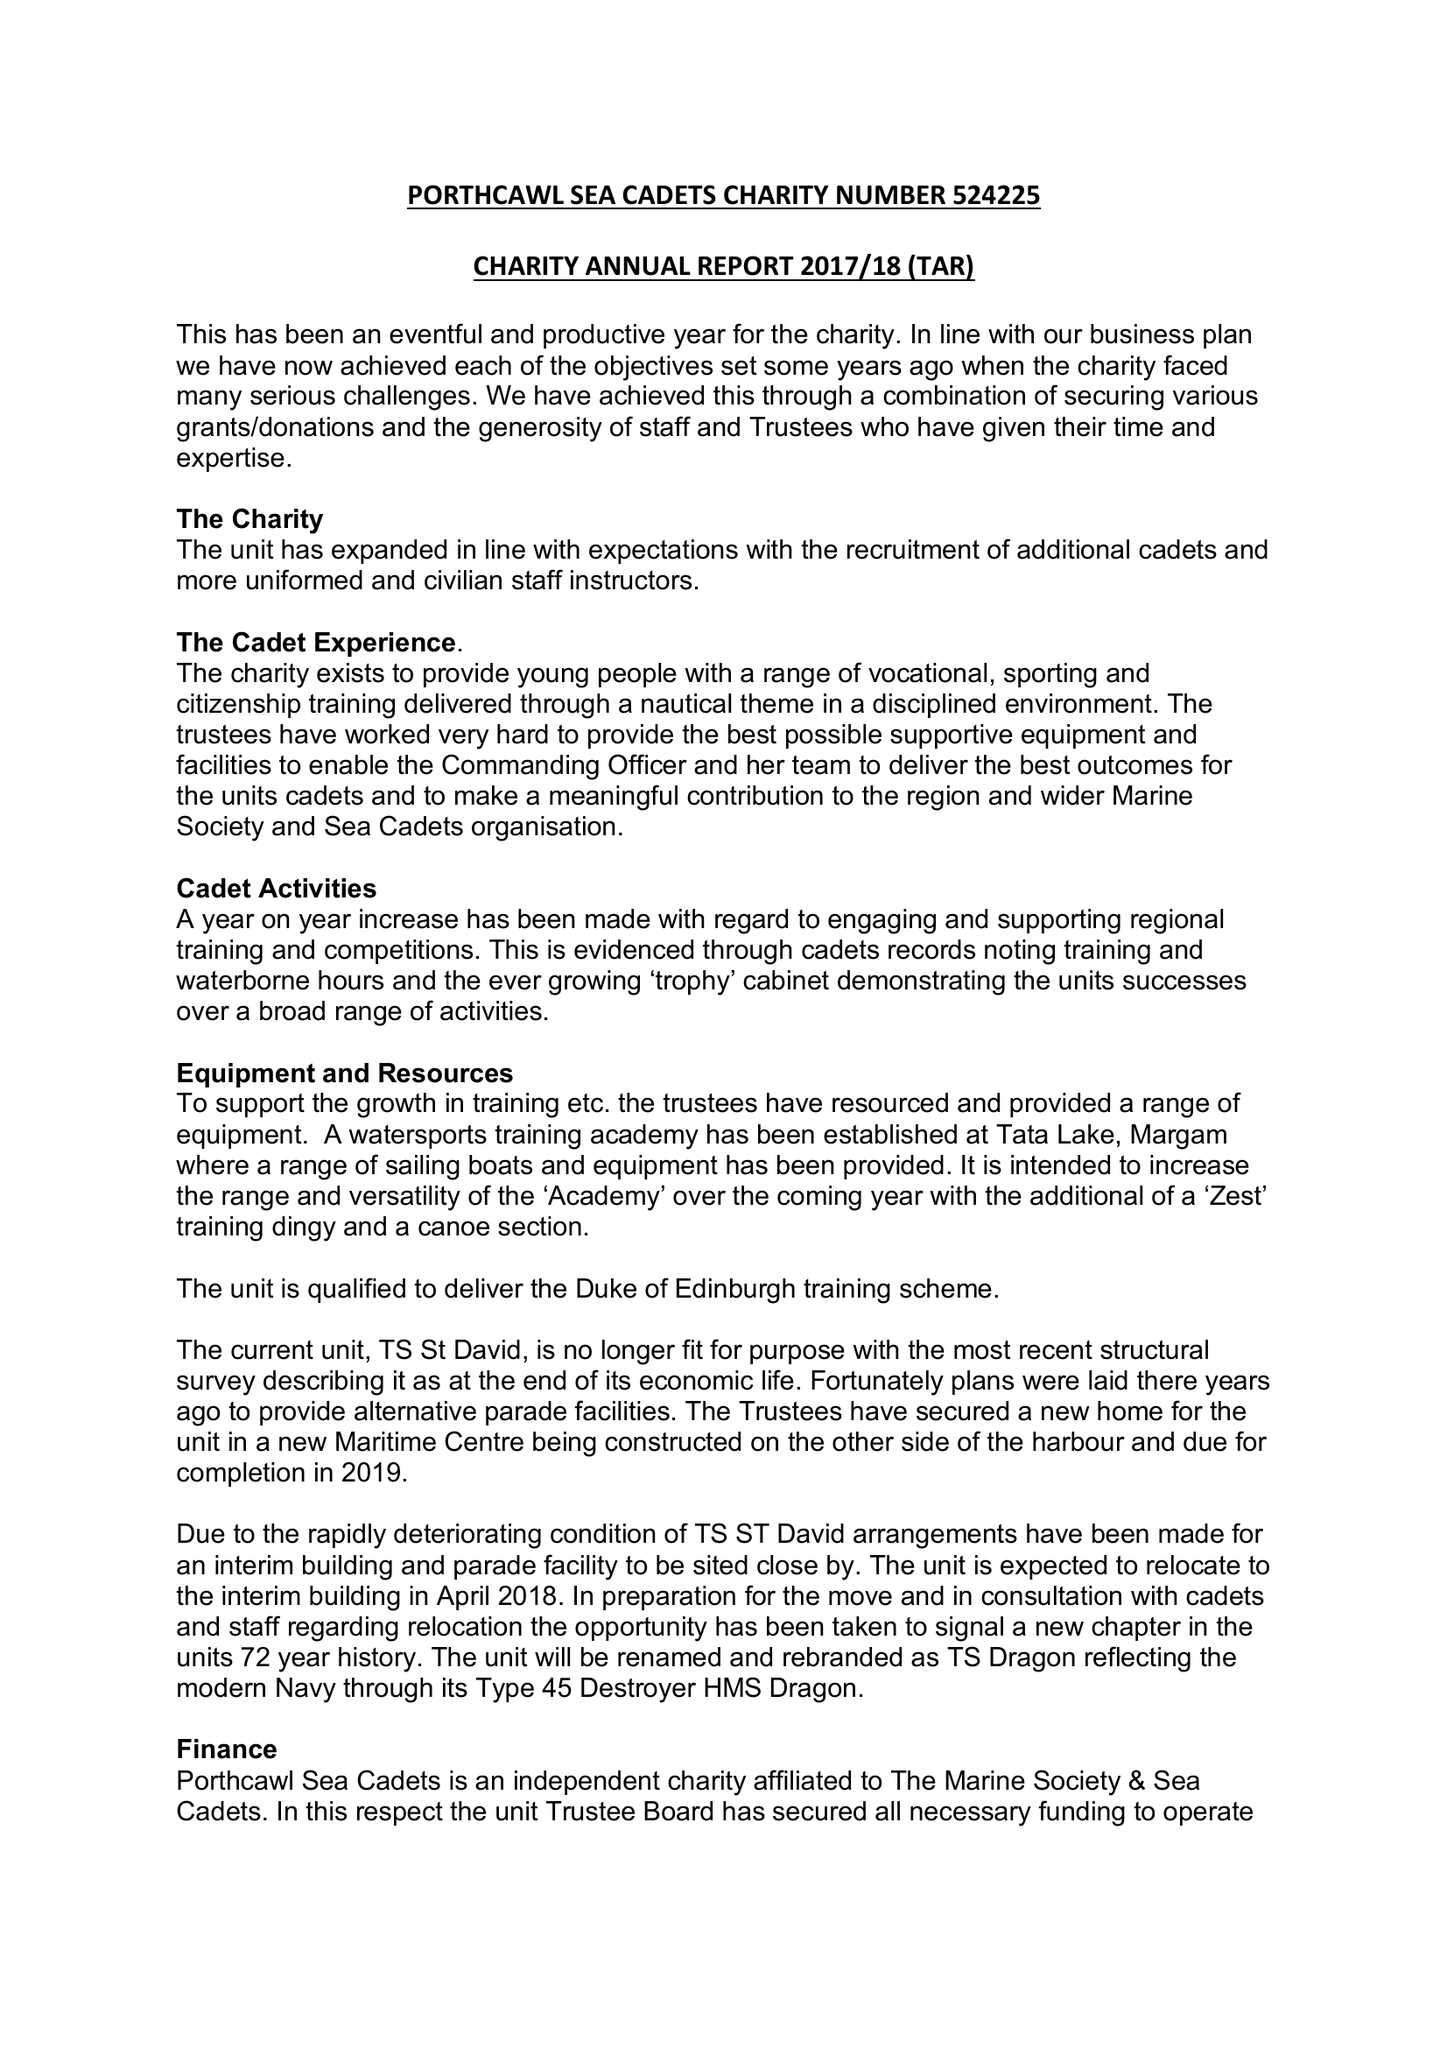What is the value for the charity_number?
Answer the question using a single word or phrase. 524225 